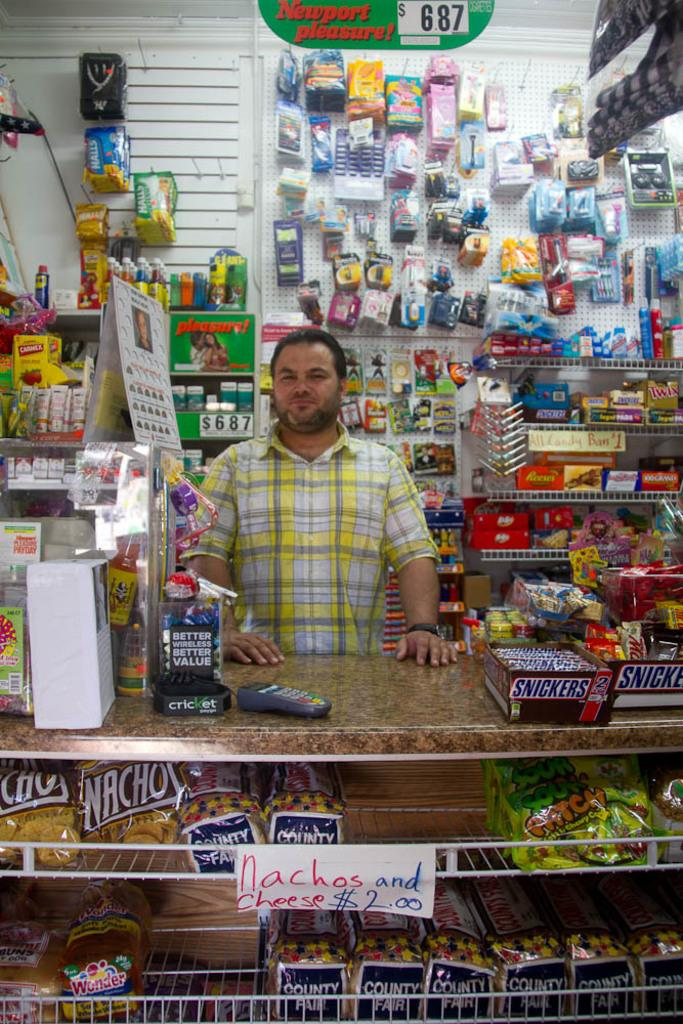<image>
Render a clear and concise summary of the photo. A store where Nachos and cheese are $2.00. 